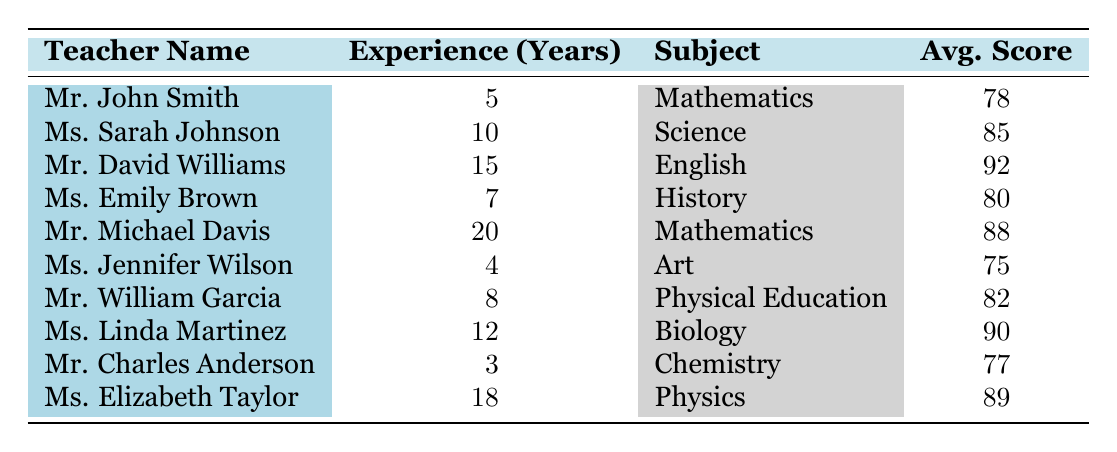What is the average student score for Mr. David Williams? Mr. David Williams has an average student score listed in the table as 92.
Answer: 92 Which subject has the highest average student score? Looking through the average student scores, Mr. David Williams in English has the highest score of 92.
Answer: English How many years of experience does Ms. Linda Martinez have? The table shows that Ms. Linda Martinez has 12 years of experience.
Answer: 12 Is the average student score for Mathematics higher than 80? Mr. John Smith has an average score of 78 and Mr. Michael Davis has an average score of 88 for Mathematics. Both scores are considered, and since 88 is greater than 80, the answer is yes.
Answer: Yes What is the average years of experience of the teachers in the table? To find the average, we first sum up the years of experience: 5 + 10 + 15 + 7 + 20 + 4 + 8 + 12 + 3 + 18 = 102. The total number of teachers is 10, so the average is 102 / 10 = 10.2.
Answer: 10.2 Which teacher has the lowest average student score? Reviewing the average student scores, Ms. Jennifer Wilson has the lowest score of 75.
Answer: Ms. Jennifer Wilson How many teachers have more than 10 years of experience? By inspecting the table, Ms. Sarah Johnson (10), Mr. David Williams (15), Mr. Michael Davis (20), Ms. Linda Martinez (12), and Ms. Elizabeth Taylor (18) have more than 10 years of experience, totaling five teachers.
Answer: 5 What is the difference in average student score between the teacher with the most experience and the teacher with the least experience? Mr. Michael Davis has 20 years of experience with an average score of 88, while Mr. Charles Anderson has 3 years of experience with an average score of 77. The difference is calculated as 88 - 77 = 11.
Answer: 11 Is there a correlation between years of experience and average student score based on the data? Comparing the years of experience against the average scores, it seems that as years of experience increase, the average student scores are higher; however, to definitively establish correlation, a statistical analysis would be needed.
Answer: Yes (but needs statistical more analysis) 